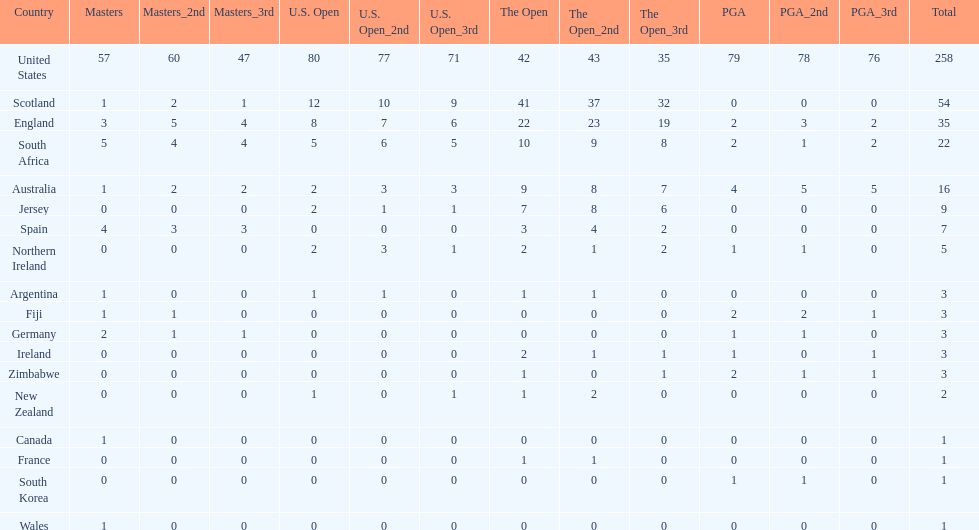Combined, how many winning golfers does england and wales have in the masters? 4. 